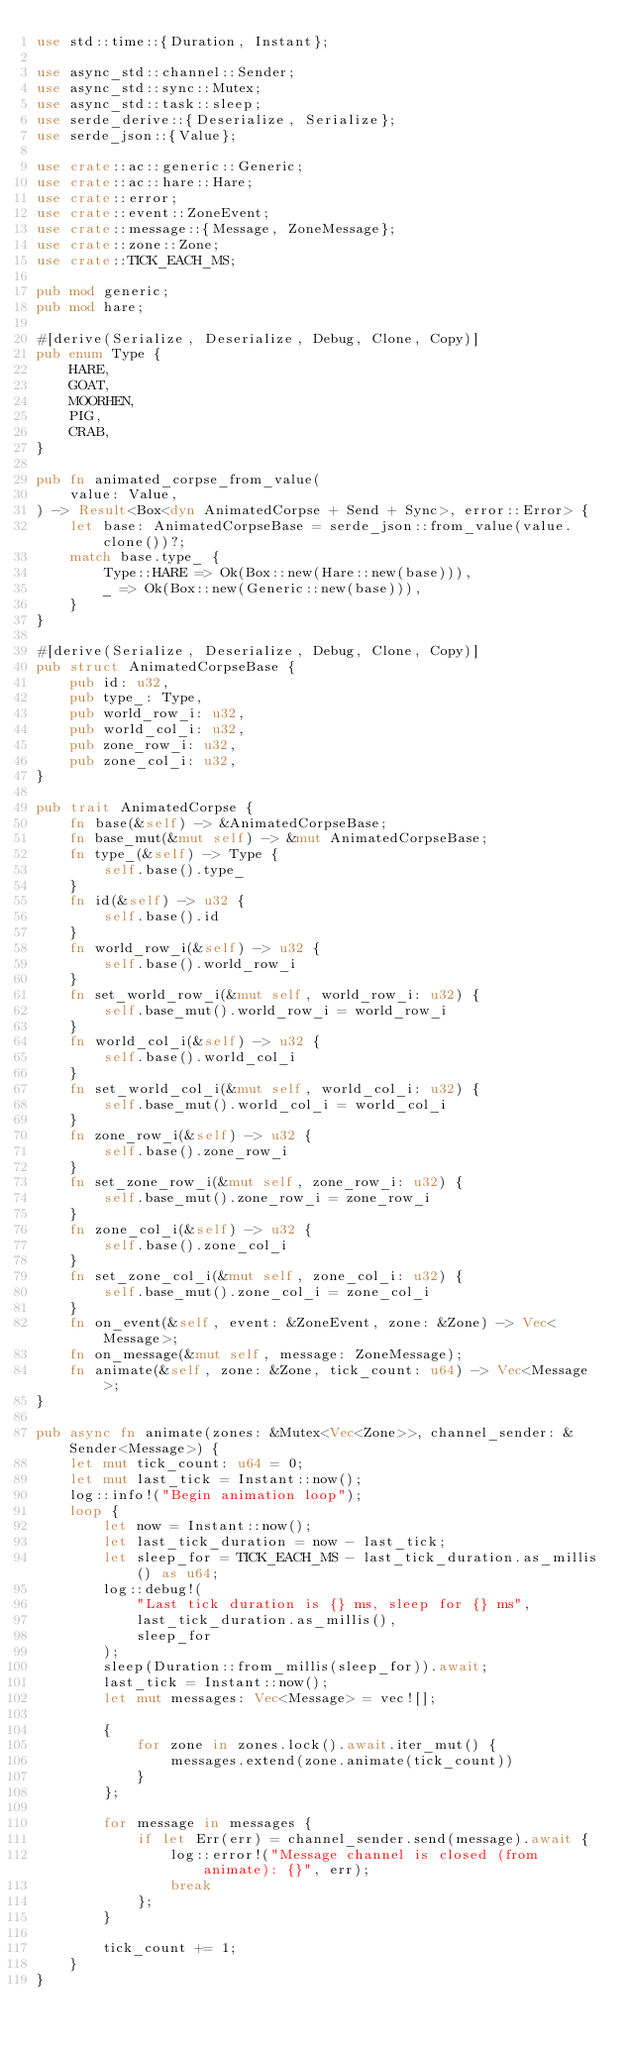<code> <loc_0><loc_0><loc_500><loc_500><_Rust_>use std::time::{Duration, Instant};

use async_std::channel::Sender;
use async_std::sync::Mutex;
use async_std::task::sleep;
use serde_derive::{Deserialize, Serialize};
use serde_json::{Value};

use crate::ac::generic::Generic;
use crate::ac::hare::Hare;
use crate::error;
use crate::event::ZoneEvent;
use crate::message::{Message, ZoneMessage};
use crate::zone::Zone;
use crate::TICK_EACH_MS;

pub mod generic;
pub mod hare;

#[derive(Serialize, Deserialize, Debug, Clone, Copy)]
pub enum Type {
    HARE,
    GOAT,
    MOORHEN,
    PIG,
    CRAB,
}

pub fn animated_corpse_from_value(
    value: Value,
) -> Result<Box<dyn AnimatedCorpse + Send + Sync>, error::Error> {
    let base: AnimatedCorpseBase = serde_json::from_value(value.clone())?;
    match base.type_ {
        Type::HARE => Ok(Box::new(Hare::new(base))),
        _ => Ok(Box::new(Generic::new(base))),
    }
}

#[derive(Serialize, Deserialize, Debug, Clone, Copy)]
pub struct AnimatedCorpseBase {
    pub id: u32,
    pub type_: Type,
    pub world_row_i: u32,
    pub world_col_i: u32,
    pub zone_row_i: u32,
    pub zone_col_i: u32,
}

pub trait AnimatedCorpse {
    fn base(&self) -> &AnimatedCorpseBase;
    fn base_mut(&mut self) -> &mut AnimatedCorpseBase;
    fn type_(&self) -> Type {
        self.base().type_
    }
    fn id(&self) -> u32 {
        self.base().id
    }
    fn world_row_i(&self) -> u32 {
        self.base().world_row_i
    }
    fn set_world_row_i(&mut self, world_row_i: u32) {
        self.base_mut().world_row_i = world_row_i
    }
    fn world_col_i(&self) -> u32 {
        self.base().world_col_i
    }
    fn set_world_col_i(&mut self, world_col_i: u32) {
        self.base_mut().world_col_i = world_col_i
    }
    fn zone_row_i(&self) -> u32 {
        self.base().zone_row_i
    }
    fn set_zone_row_i(&mut self, zone_row_i: u32) {
        self.base_mut().zone_row_i = zone_row_i
    }
    fn zone_col_i(&self) -> u32 {
        self.base().zone_col_i
    }
    fn set_zone_col_i(&mut self, zone_col_i: u32) {
        self.base_mut().zone_col_i = zone_col_i
    }
    fn on_event(&self, event: &ZoneEvent, zone: &Zone) -> Vec<Message>;
    fn on_message(&mut self, message: ZoneMessage);
    fn animate(&self, zone: &Zone, tick_count: u64) -> Vec<Message>;
}

pub async fn animate(zones: &Mutex<Vec<Zone>>, channel_sender: &Sender<Message>) {
    let mut tick_count: u64 = 0;
    let mut last_tick = Instant::now();
    log::info!("Begin animation loop");
    loop {
        let now = Instant::now();
        let last_tick_duration = now - last_tick;
        let sleep_for = TICK_EACH_MS - last_tick_duration.as_millis() as u64;
        log::debug!(
            "Last tick duration is {} ms, sleep for {} ms",
            last_tick_duration.as_millis(),
            sleep_for
        );
        sleep(Duration::from_millis(sleep_for)).await;
        last_tick = Instant::now();
        let mut messages: Vec<Message> = vec![];

        {
            for zone in zones.lock().await.iter_mut() {
                messages.extend(zone.animate(tick_count))
            }
        };

        for message in messages {
            if let Err(err) = channel_sender.send(message).await {
                log::error!("Message channel is closed (from animate): {}", err);
                break
            };
        }

        tick_count += 1;
    }
}
</code> 